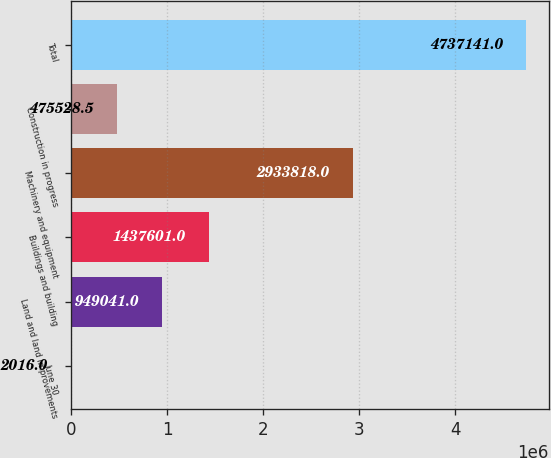Convert chart to OTSL. <chart><loc_0><loc_0><loc_500><loc_500><bar_chart><fcel>June 30<fcel>Land and land improvements<fcel>Buildings and building<fcel>Machinery and equipment<fcel>Construction in progress<fcel>Total<nl><fcel>2016<fcel>949041<fcel>1.4376e+06<fcel>2.93382e+06<fcel>475528<fcel>4.73714e+06<nl></chart> 